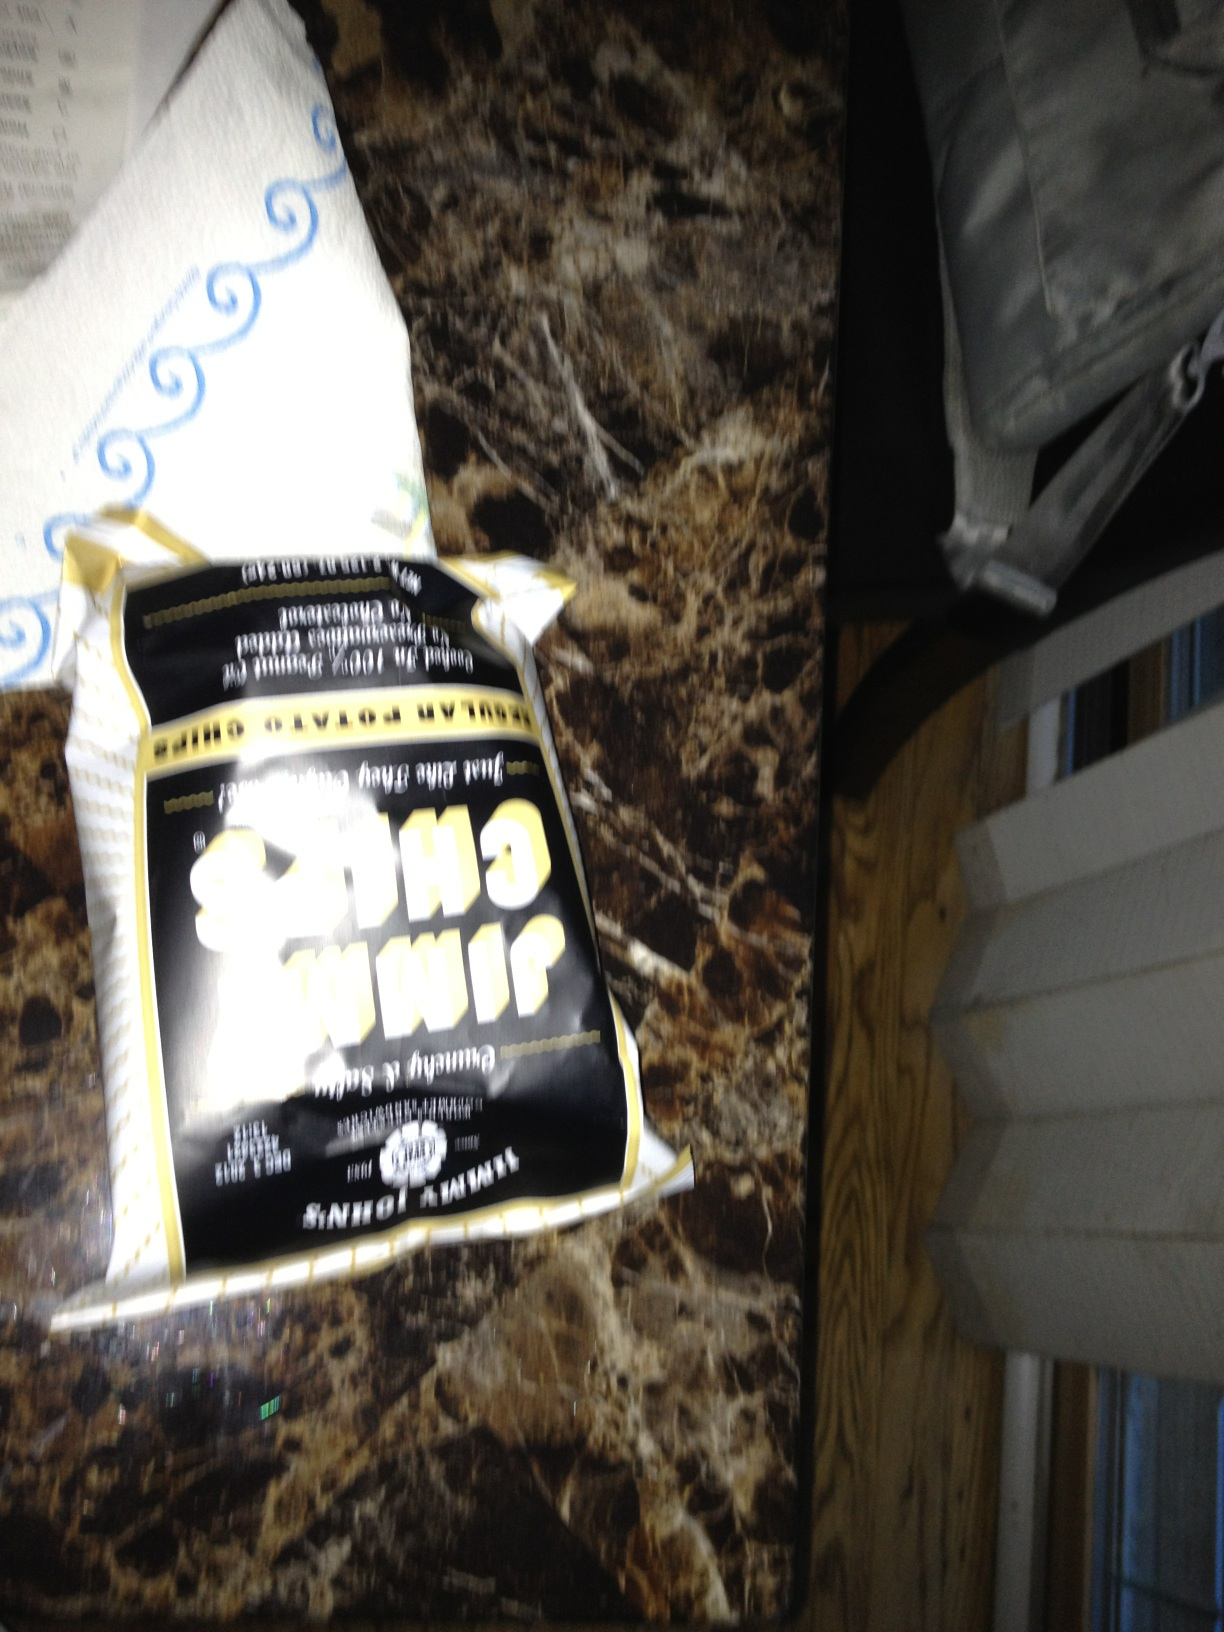What kinda chips are these? While the image quality and angle make it challenging to determine the exact brand or type of chips, the packaging suggests that these appear to be a savory snack, possibly with a cheese or onion flavor, given the common color themes and patterns used for such flavors. Without a clearer view, I cannot provide a specific brand or variety. 